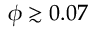<formula> <loc_0><loc_0><loc_500><loc_500>\phi \gtrsim 0 . 0 7</formula> 